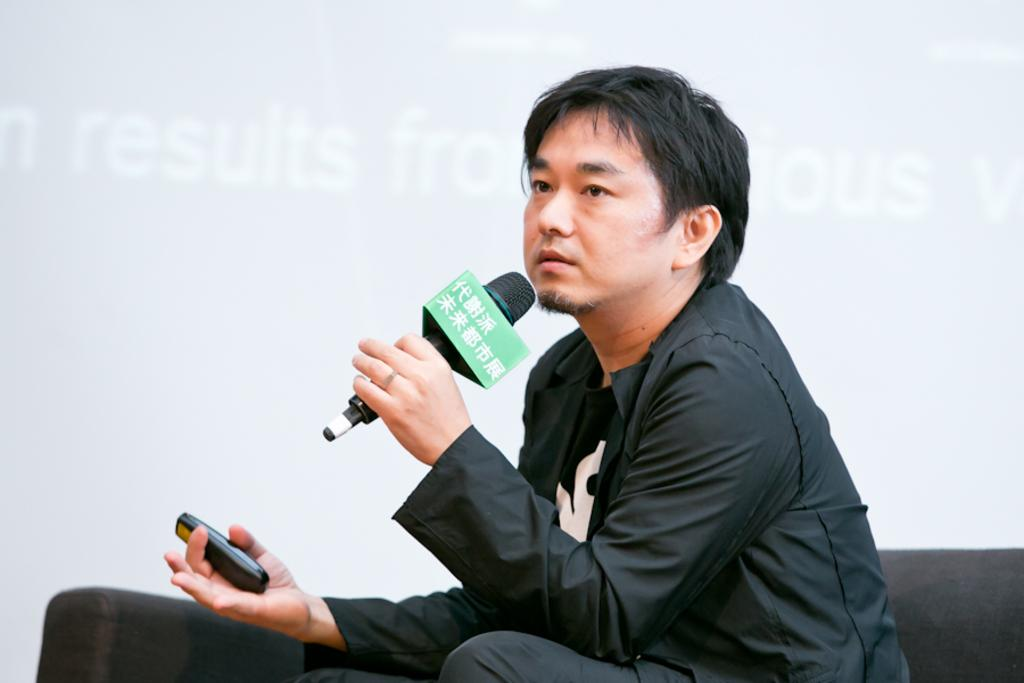What is the main subject of the image? The main subject of the image is a man. What is the man doing in the image? The man is sitting on a sofa and holding a mic in one hand and a remote in the other hand. What can be seen in the background of the image? There is a screen in the background of the image. What type of sticks is the man using to drive in the image? There is no indication in the image that the man is driving or using any sticks. 